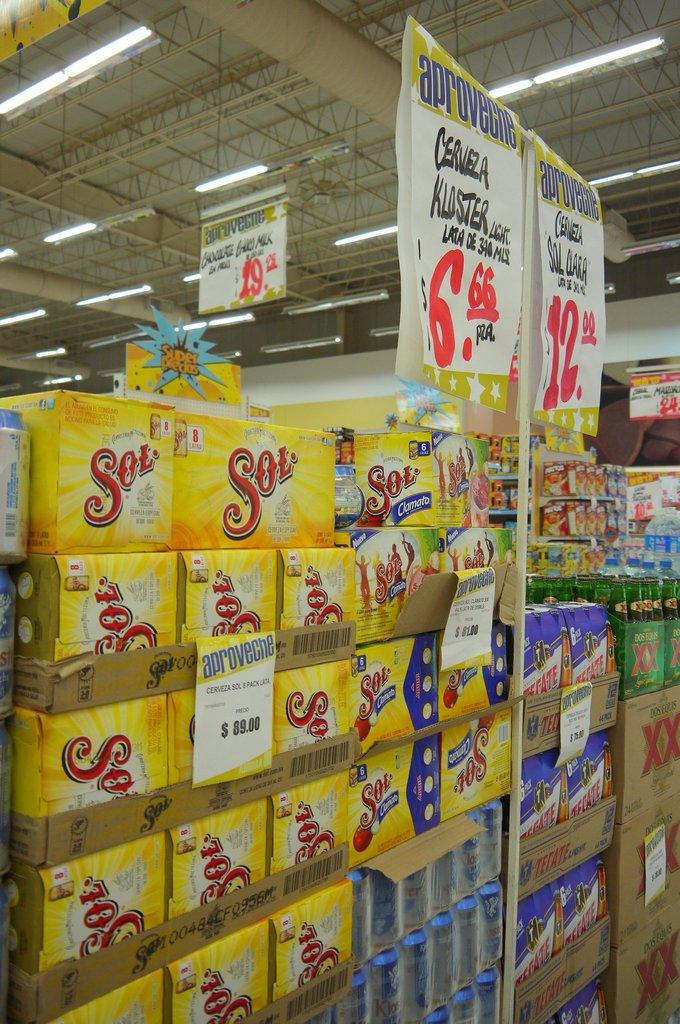What is the main subject of the image? The main subject of the image is the arrangement of boxes. Are there any additional elements in the image? Yes, there are banners in the image. What can be seen above the boxes and banners? There is a ceiling visible in the image. What is present on the ceiling? There are lights on the ceiling. What type of insurance policy is advertised on the banners in the image? There is no insurance policy advertised on the banners in the image; they are not related to insurance. 